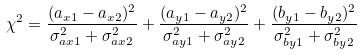<formula> <loc_0><loc_0><loc_500><loc_500>\chi ^ { 2 } = \frac { ( a _ { x 1 } - a _ { x 2 } ) ^ { 2 } } { \sigma _ { a x 1 } ^ { 2 } + \sigma _ { a x 2 } ^ { 2 } } + \frac { ( a _ { y 1 } - a _ { y 2 } ) ^ { 2 } } { \sigma _ { a y 1 } ^ { 2 } + \sigma _ { a y 2 } ^ { 2 } } + \frac { ( b _ { y 1 } - b _ { y 2 } ) ^ { 2 } } { \sigma _ { b y 1 } ^ { 2 } + \sigma _ { b y 2 } ^ { 2 } }</formula> 